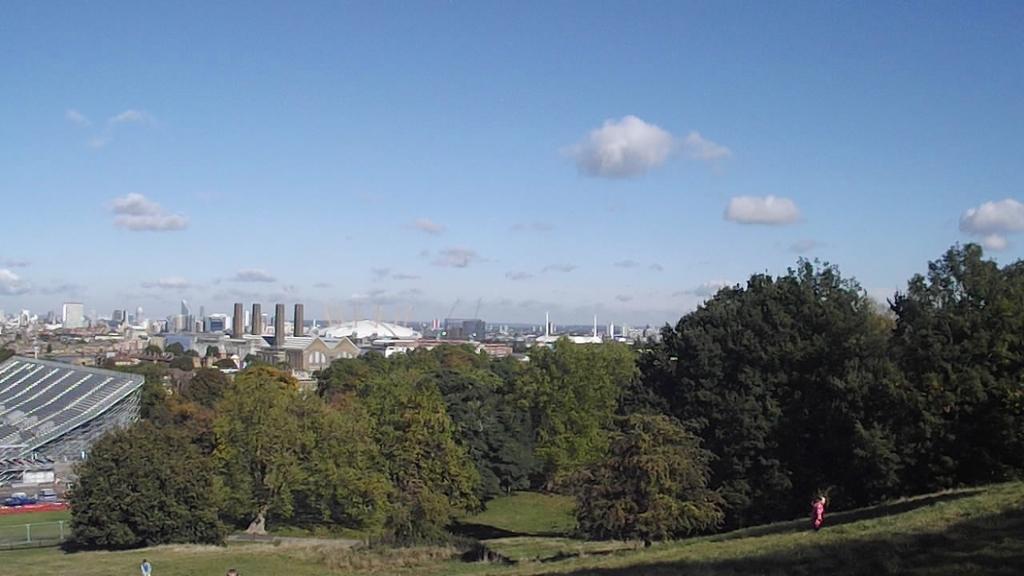Describe this image in one or two sentences. In this picture we can see buildings, trees, grass and sky. These are clouds. 